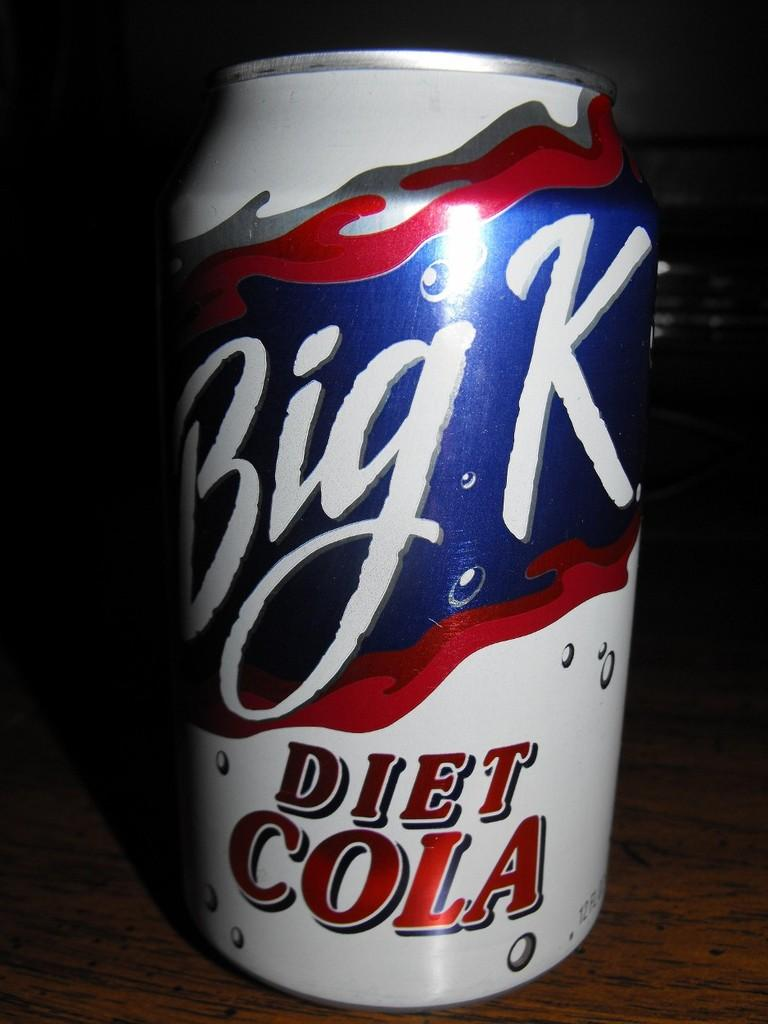<image>
Describe the image concisely. A can of Big K, Diet Cola is sitting on a wooden surface. 